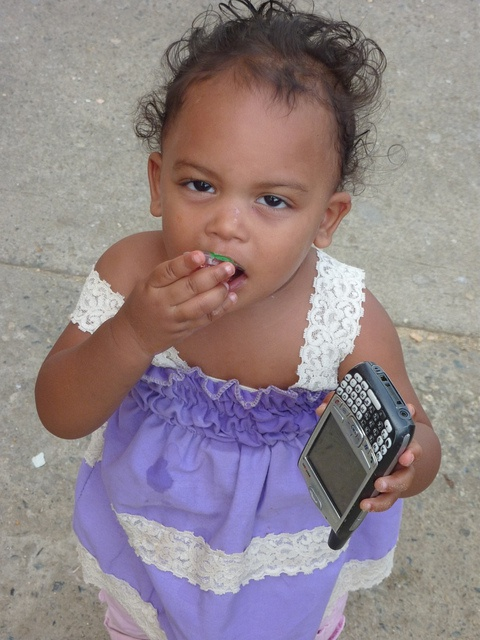Describe the objects in this image and their specific colors. I can see people in darkgray, gray, and violet tones and cell phone in darkgray, gray, and black tones in this image. 